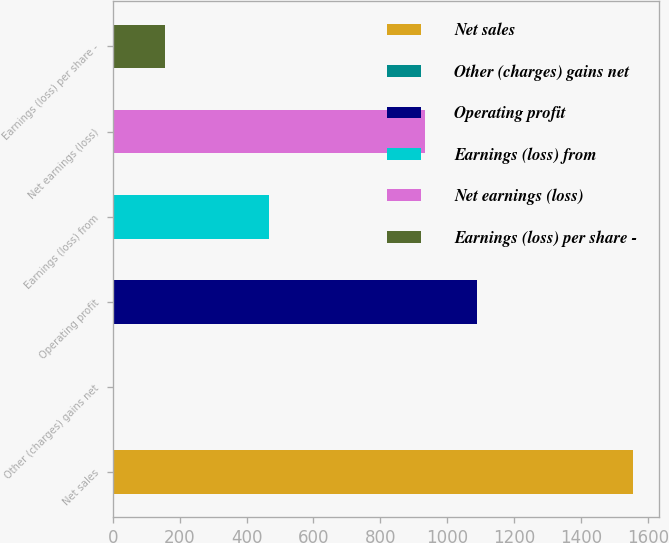Convert chart to OTSL. <chart><loc_0><loc_0><loc_500><loc_500><bar_chart><fcel>Net sales<fcel>Other (charges) gains net<fcel>Operating profit<fcel>Earnings (loss) from<fcel>Net earnings (loss)<fcel>Earnings (loss) per share -<nl><fcel>1555<fcel>1<fcel>1088.8<fcel>467.2<fcel>933.4<fcel>156.4<nl></chart> 